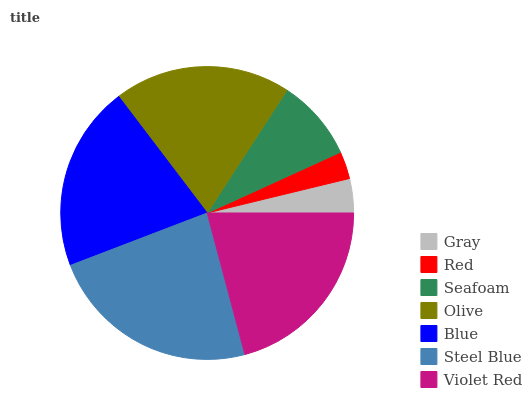Is Red the minimum?
Answer yes or no. Yes. Is Steel Blue the maximum?
Answer yes or no. Yes. Is Seafoam the minimum?
Answer yes or no. No. Is Seafoam the maximum?
Answer yes or no. No. Is Seafoam greater than Red?
Answer yes or no. Yes. Is Red less than Seafoam?
Answer yes or no. Yes. Is Red greater than Seafoam?
Answer yes or no. No. Is Seafoam less than Red?
Answer yes or no. No. Is Olive the high median?
Answer yes or no. Yes. Is Olive the low median?
Answer yes or no. Yes. Is Blue the high median?
Answer yes or no. No. Is Violet Red the low median?
Answer yes or no. No. 